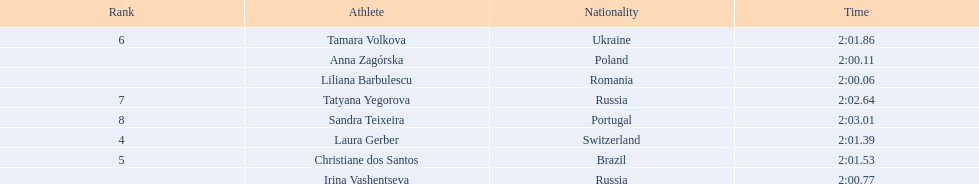What is the number of russian participants in this set of semifinals? 2. 